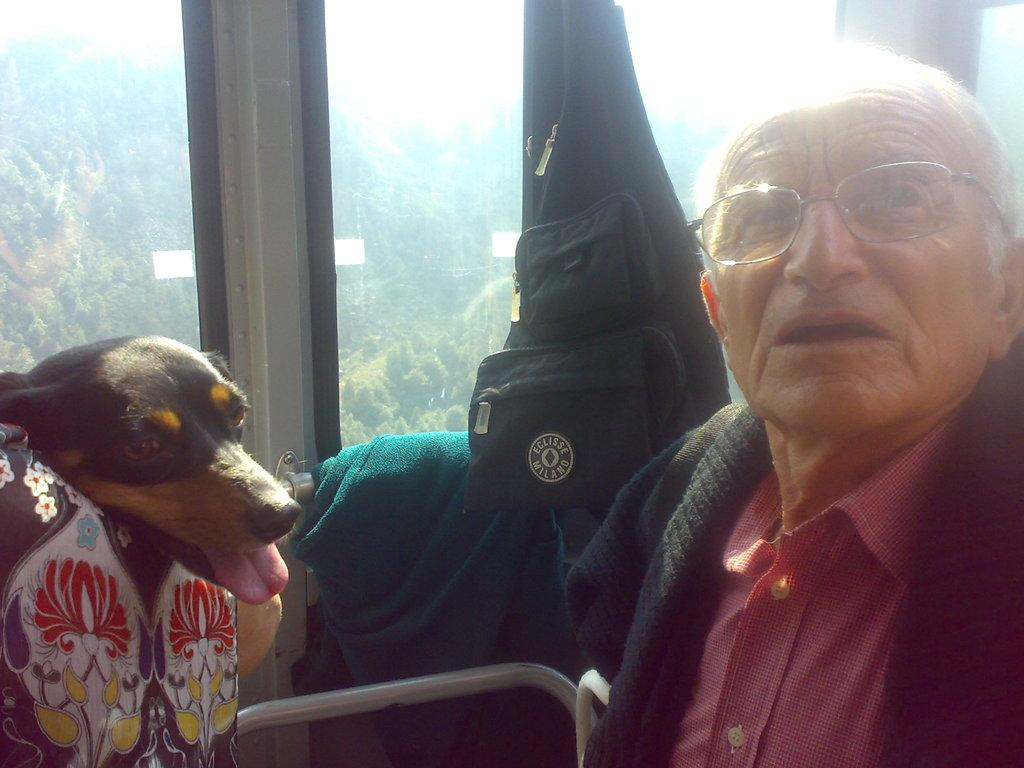Who is present in the image? There is a man in the image. What is the man wearing on his upper body? The man is wearing a red t-shirt. What accessory is the man wearing on his face? The man is wearing glasses (specs). What other living creature is in the image? There is a dog in the image. What object can be seen in the image that might be used for carrying items? There is a bag in the image. What can be seen in the background of the image? There are trees in the background of the image. What type of liquid is being poured from the iron in the image? There is no liquid or iron present in the image. What type of sponge is being used to clean the dog in the image? There is no sponge or cleaning activity involving the dog in the image. 